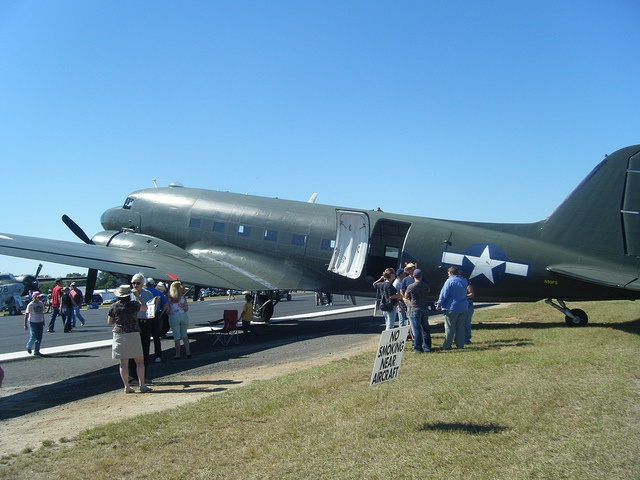Describe the objects in this image and their specific colors. I can see airplane in lightblue, black, gray, and blue tones, people in lightblue, black, gray, navy, and blue tones, people in lightblue, gray, black, darkgray, and lightgray tones, people in lightblue, navy, black, darkblue, and gray tones, and people in lightblue, black, navy, blue, and white tones in this image. 